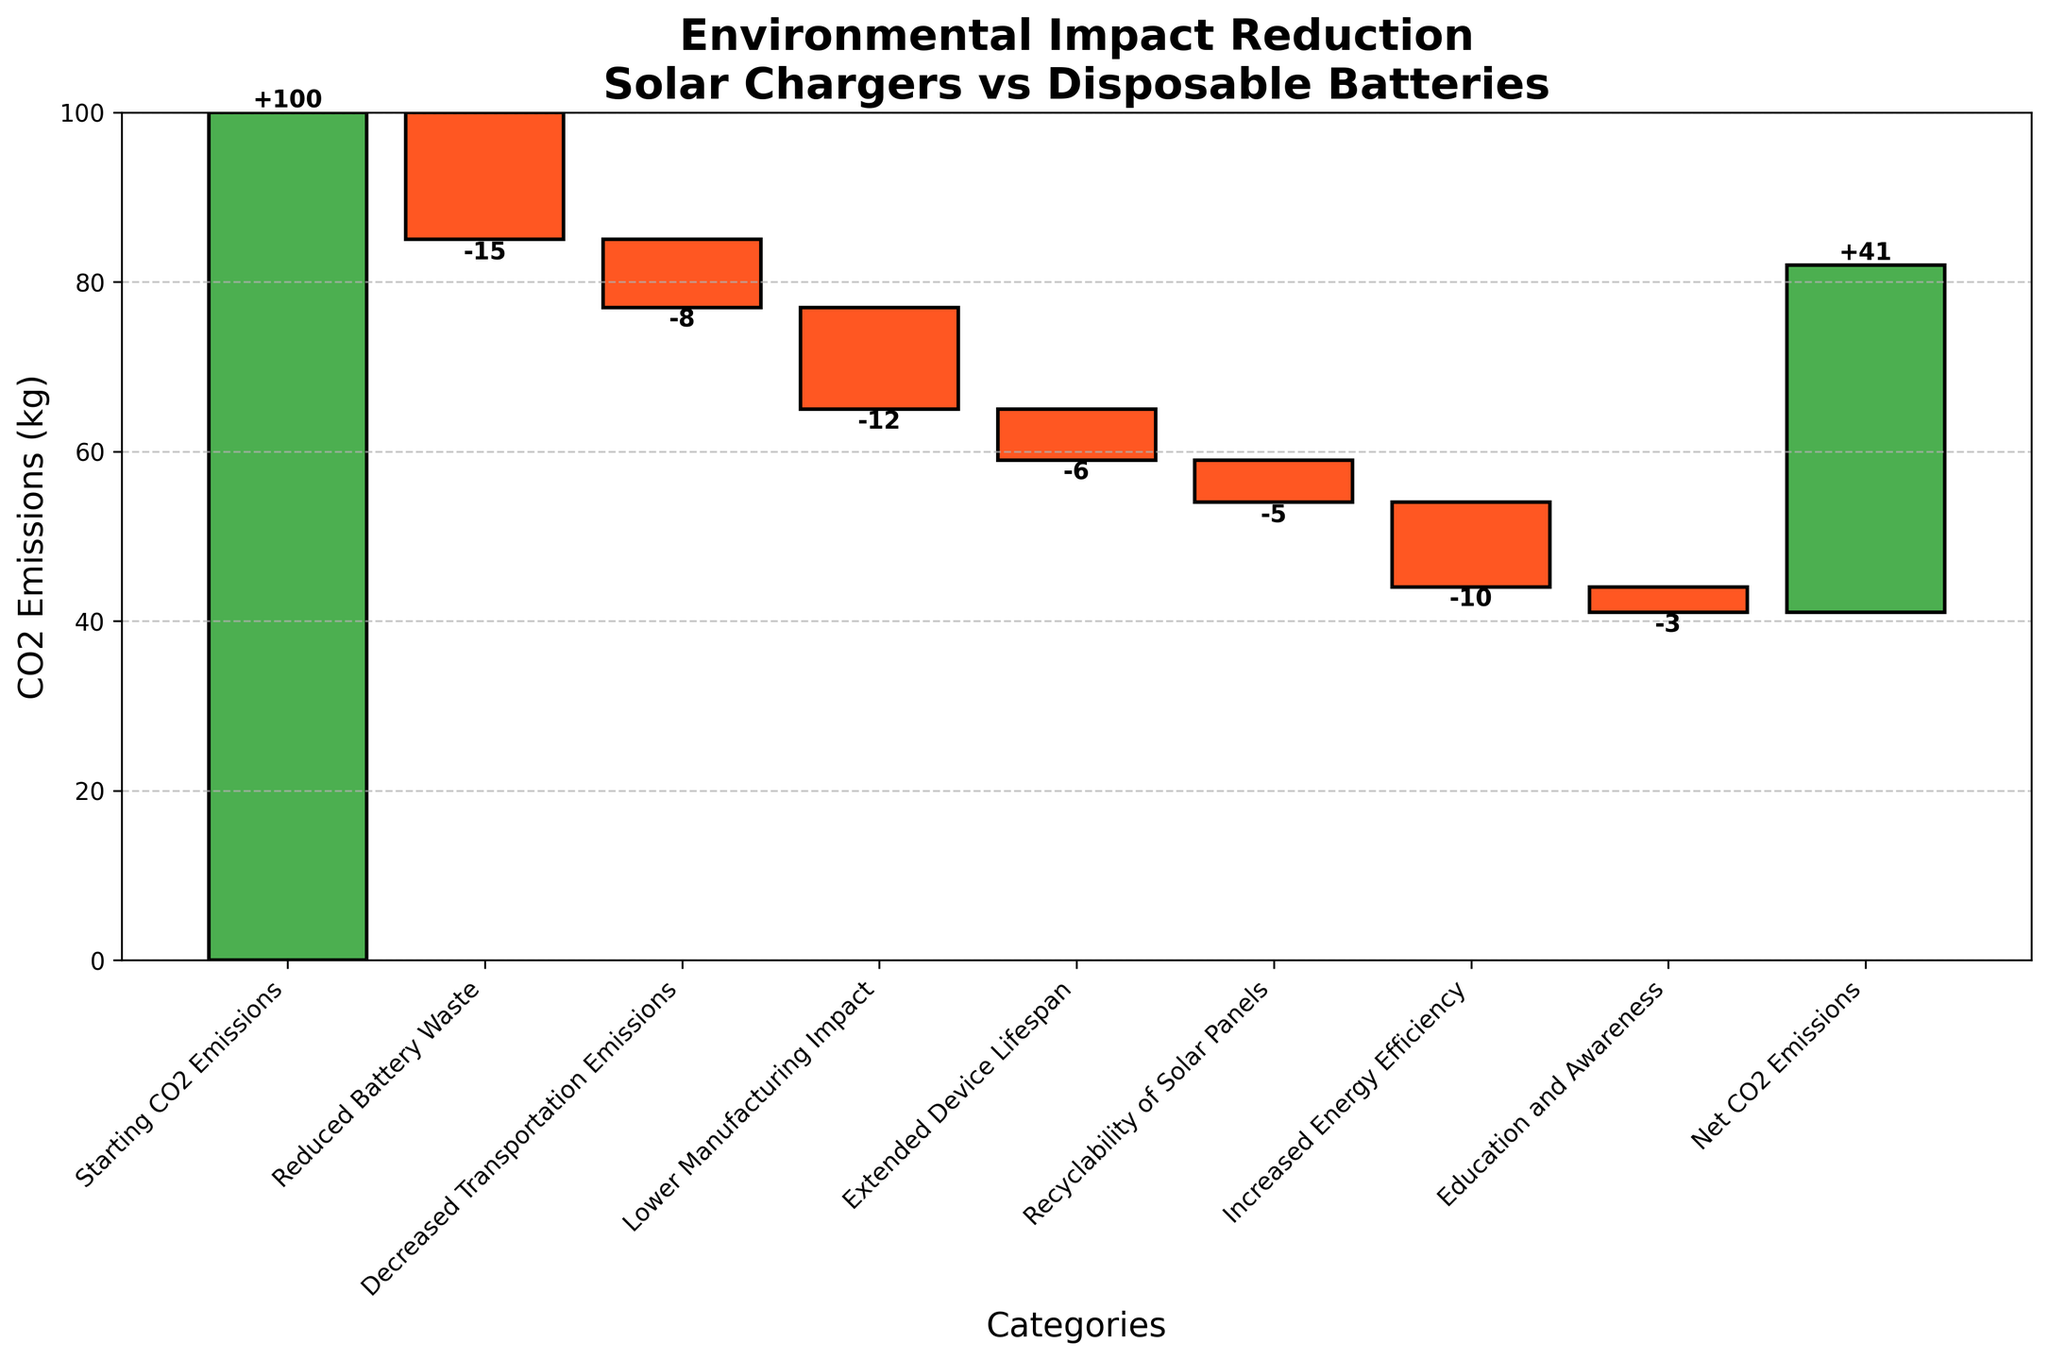What is the title of the figure? The title of the figure can be found at the top of the plot. It reads "Environmental Impact Reduction\nSolar Chargers vs Disposable Batteries".
Answer: Environmental Impact Reduction\nSolar Chargers vs Disposable Batteries How many categories are there in total on the x-axis? The x-axis labels each category. Counting these labels, there are a total of 9 categories.
Answer: 9 What is the value for "Reduced Battery Waste"? Look at the bar labeled "Reduced Battery Waste". Next to it is the value, which is -15.
Answer: -15 What is the net CO2 Emissions value after all reductions? The Net CO2 Emissions can be found as the final value in the waterfall chart, which is labeled and marked at the end. It is 41.
Answer: 41 Which category has the largest single negative impact on CO2 emissions? Review the negative bars to see which one has the highest absolute value. "Reduced Battery Waste" has the most significant single impact with -15.
Answer: Reduced Battery Waste How much is the cumulative reduction in CO2 emissions from all categories except the starting value and net emissions? Sum all the negative impacts: -15 (Reduced Battery Waste) + -8 (Decreased Transportation Emissions) + -12 (Lower Manufacturing Impact) + -6 (Extended Device Lifespan) + -5 (Recyclability of Solar Panels) + -10 (Increased Energy Efficiency) + -3 (Education and Awareness) = -59
Answer: -59 What is the cumulative value after "Decreased Transportation Emissions"? Starting CO2 Emissions is 100, so after "Decreased Transportation Emissions", which is -8, the cumulative value is 100 - 8 = 92.
Answer: 92 Compare the impact of "Increased Energy Efficiency" against "Education and Awareness". What do you find? "Increased Energy Efficiency" reduces CO2 emissions by -10, while "Education and Awareness" reduces them by -3. Therefore, the impact of "Increased Energy Efficiency" is greater than "Education and Awareness".
Answer: Increased Energy Efficiency has greater impact What is the cumulative effect of "Lower Manufacturing Impact" and "Extended Device Lifespan"? The cumulative effect requires summing the values: -12 (Lower Manufacturing Impact) + -6 (Extended Device Lifespan) = -18.
Answer: -18 